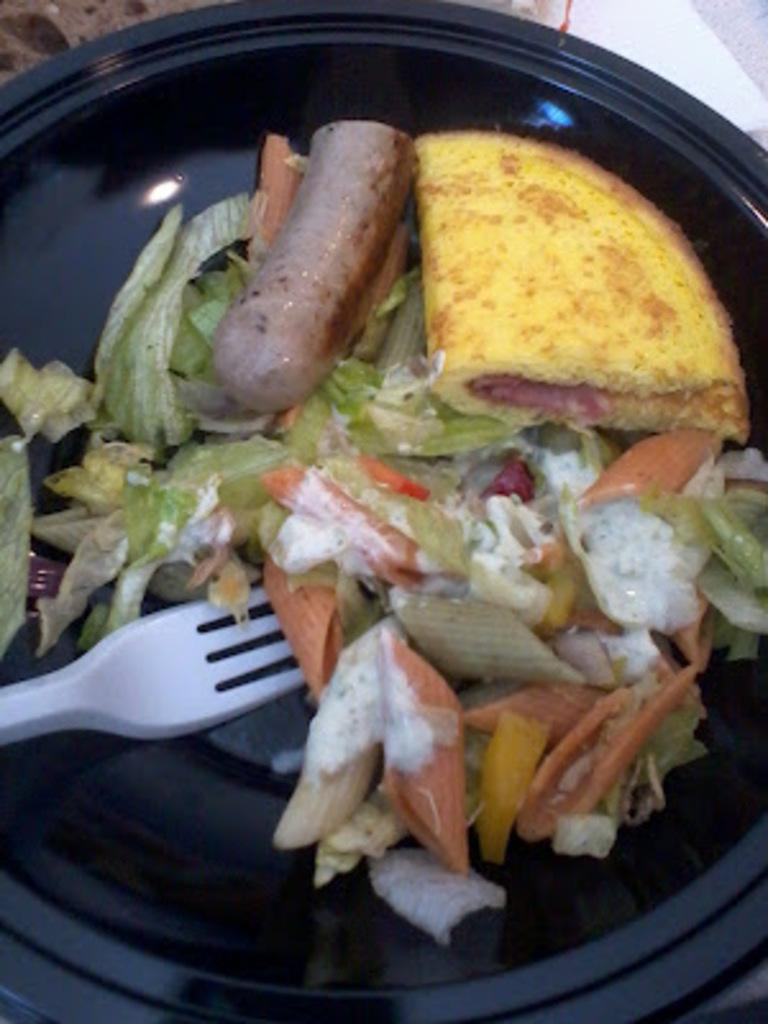What is on the plate that is visible in the image? There is a plate filled with food items in the image. What utensil is visible in the image? There is a fork visible in the image. How many lizards are sitting on the plate in the image? There are no lizards present in the image; it only shows a plate filled with food items and a fork. What type of stew is being served on the plate in the image? There is no stew visible in the image; it only shows a plate filled with food items. 